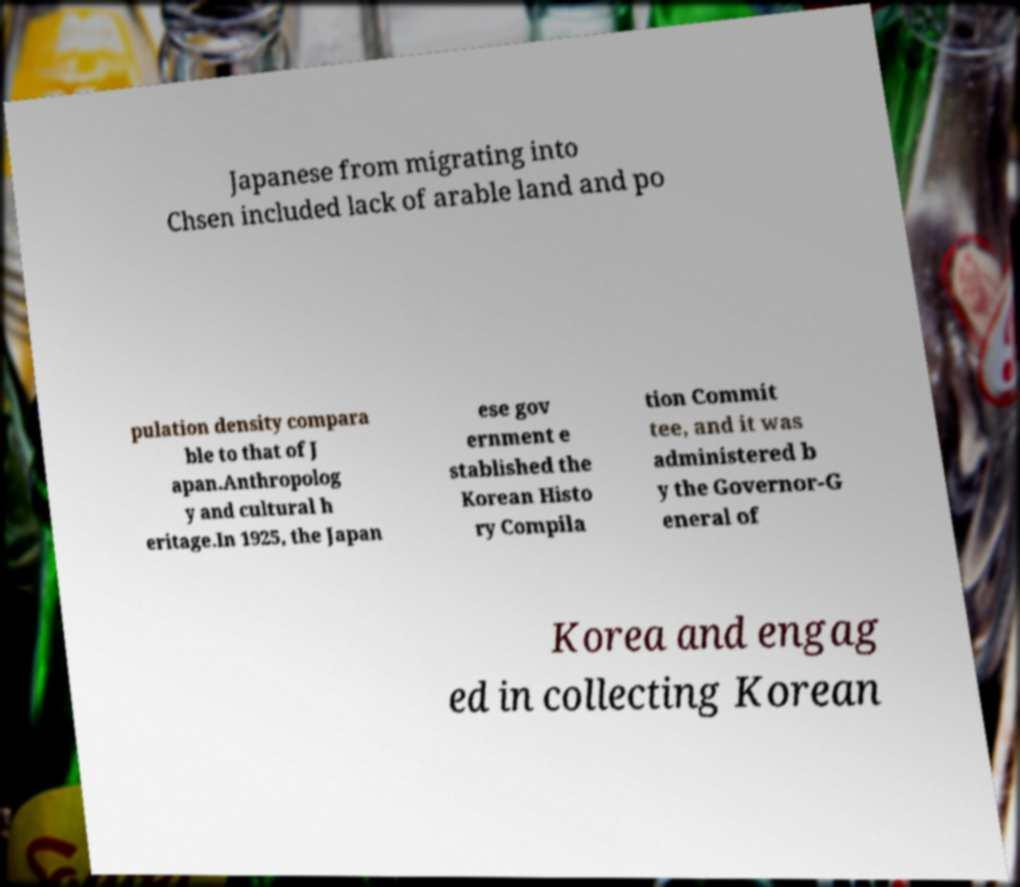Please identify and transcribe the text found in this image. Japanese from migrating into Chsen included lack of arable land and po pulation density compara ble to that of J apan.Anthropolog y and cultural h eritage.In 1925, the Japan ese gov ernment e stablished the Korean Histo ry Compila tion Commit tee, and it was administered b y the Governor-G eneral of Korea and engag ed in collecting Korean 